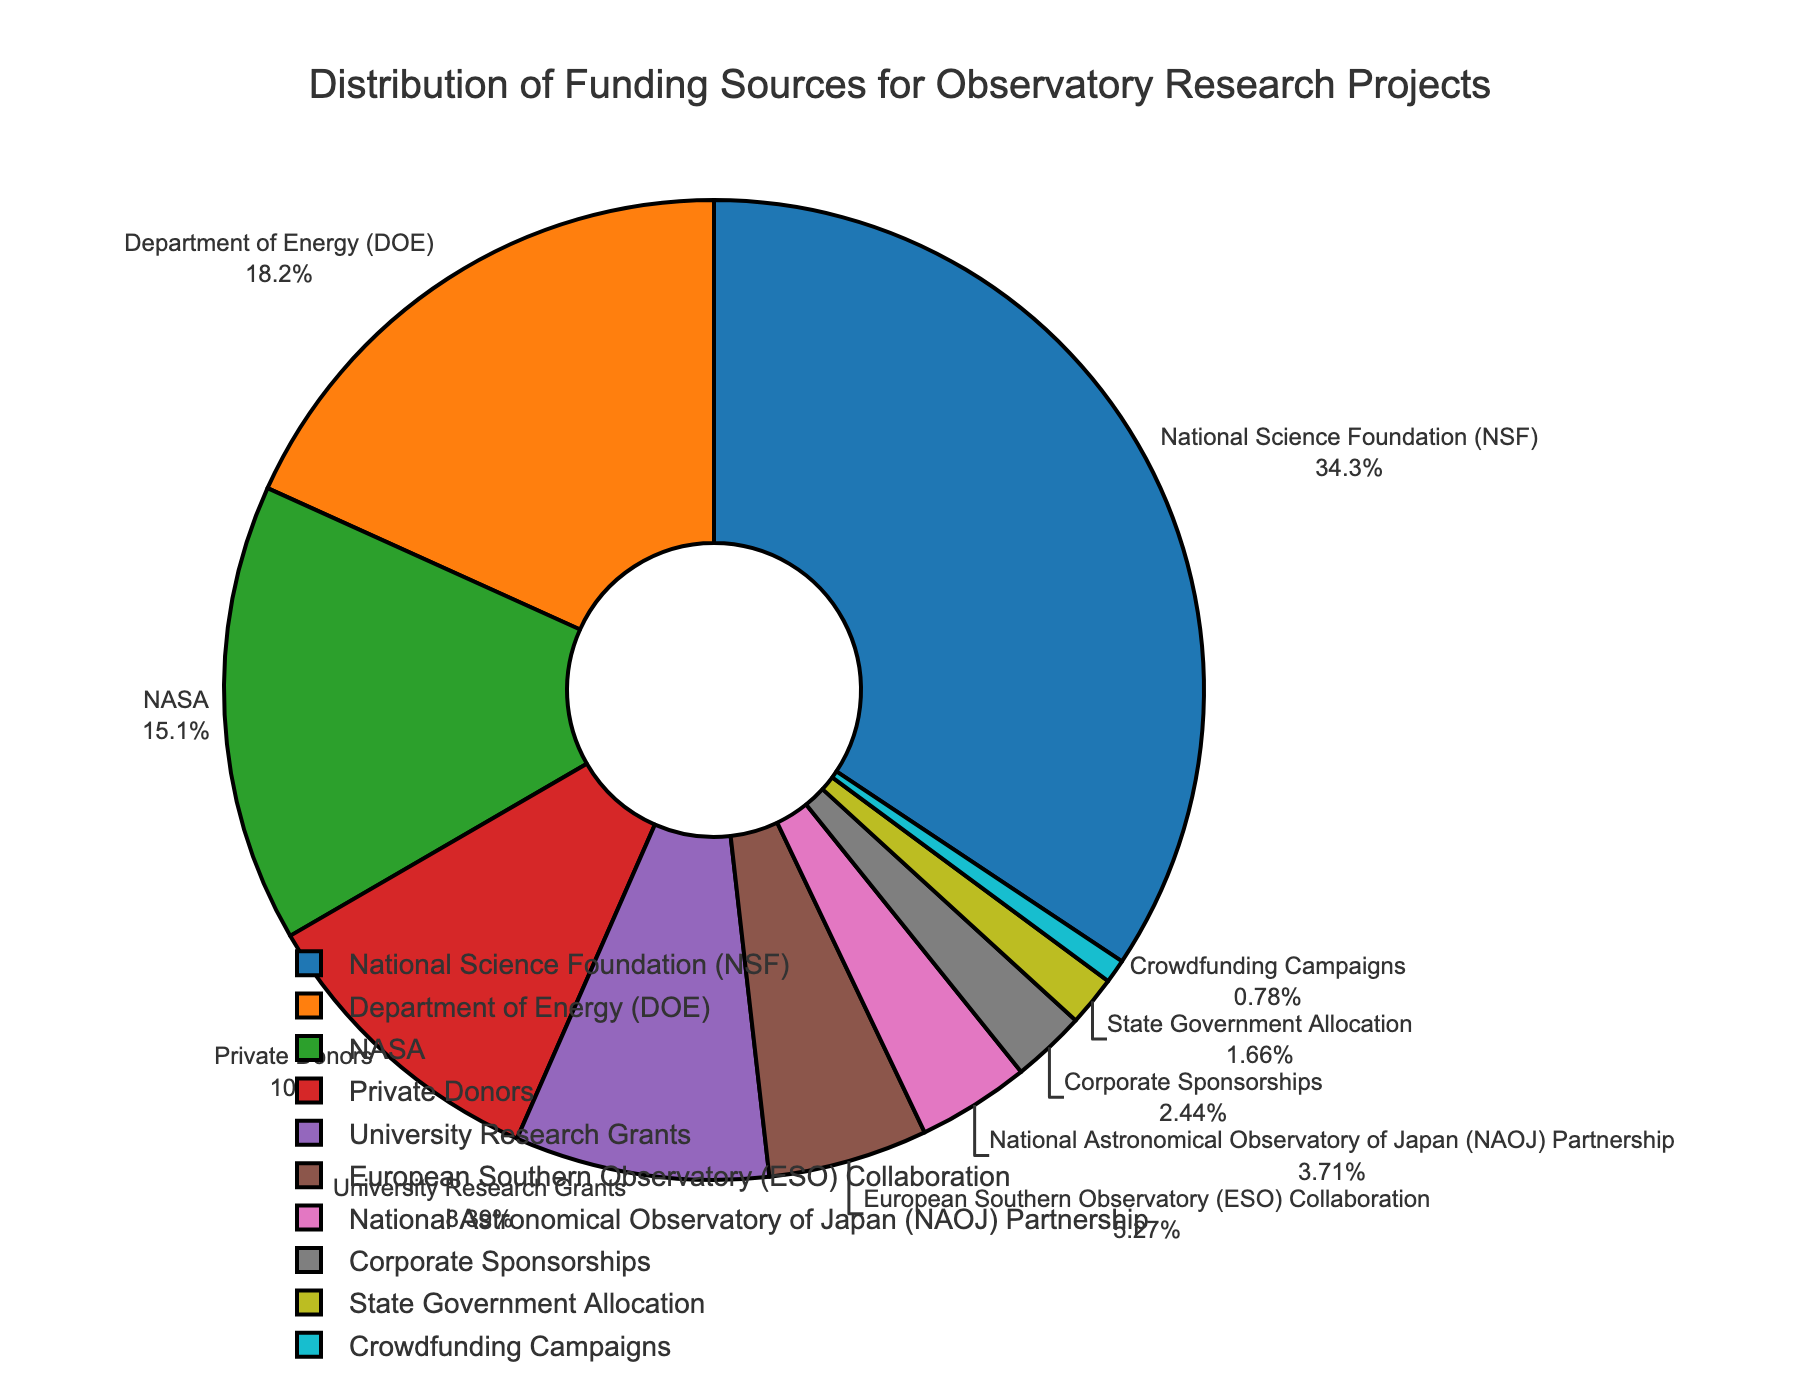What is the most significant funding source? The largest segment in the pie chart represents the National Science Foundation (NSF) with a percentage of 35.2.
Answer: National Science Foundation (NSF) Which funding source contributes the lowest percentage to the observatory's research projects? The smallest segment belongs to Crowdfunding Campaigns with a percentage of 0.8.
Answer: Crowdfunding Campaigns How much more does the National Science Foundation (NSF) contribute compared to the Department of Energy (DOE)? NSF contributes 35.2%, and DOE contributes 18.7%. The difference is 35.2 - 18.7 = 16.5.
Answer: 16.5% Which funding sources contribute more than 10% to the observatory's research projects? By examining the labels and percentages, NSF (35.2%), DOE (18.7%), and NASA (15.5%) contribute more than 10%.
Answer: NSF, DOE, NASA If we combine the contributions from Private Donors and University Research Grants, what is their total contribution percentage? Private Donors contribute 10.3%, and University Research Grants contribute 8.6%. Their combined contribution is 10.3 + 8.6 = 18.9.
Answer: 18.9% Between the European Southern Observatory (ESO) Collaboration and the National Astronomical Observatory of Japan (NAOJ) Partnership, which has a larger contribution, and by how much? ESO contributes 5.4%, and NAOJ contributes 3.8%. The difference is 5.4 - 3.8 = 1.6.
Answer: ESO Collaboration by 1.6% What is the combined contribution percentage of all international collaborations listed? The international collaborations listed are ESO (5.4%) and NAOJ (3.8%). Their combined percentage is 5.4 + 3.8 = 9.2.
Answer: 9.2% Visually, what is the color representation of the funding source with the third-largest contribution? The third-largest contribution comes from NASA, which is visually represented in green on the pie chart.
Answer: Green Which three funding sources make up the smallest combined percentage, and what is their total percentage? The three smallest contributions come from Crowdfunding Campaigns (0.8%), State Government Allocation (1.7%), and Corporate Sponsorships (2.5%). Their total combined percentage is 0.8 + 1.7 + 2.5 = 5.0.
Answer: Crowdfunding Campaigns, State Government Allocation, Corporate Sponsorships, 5.0% 